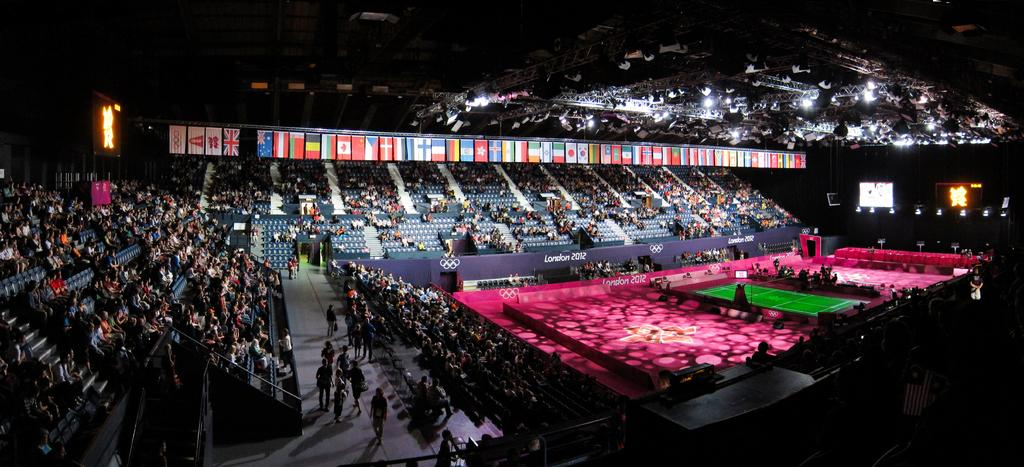What type of venue is depicted in the image? There is an indoor stadium in the image. How are people arranged in the stadium? People are sitting on chairs in the stadium, and some are standing at the top. What additional elements can be seen in the image? There are flags and lights in the image. What songs are being sung by the people in the image? There is no information about songs being sung in the image; it only shows people sitting and standing in an indoor stadium. 